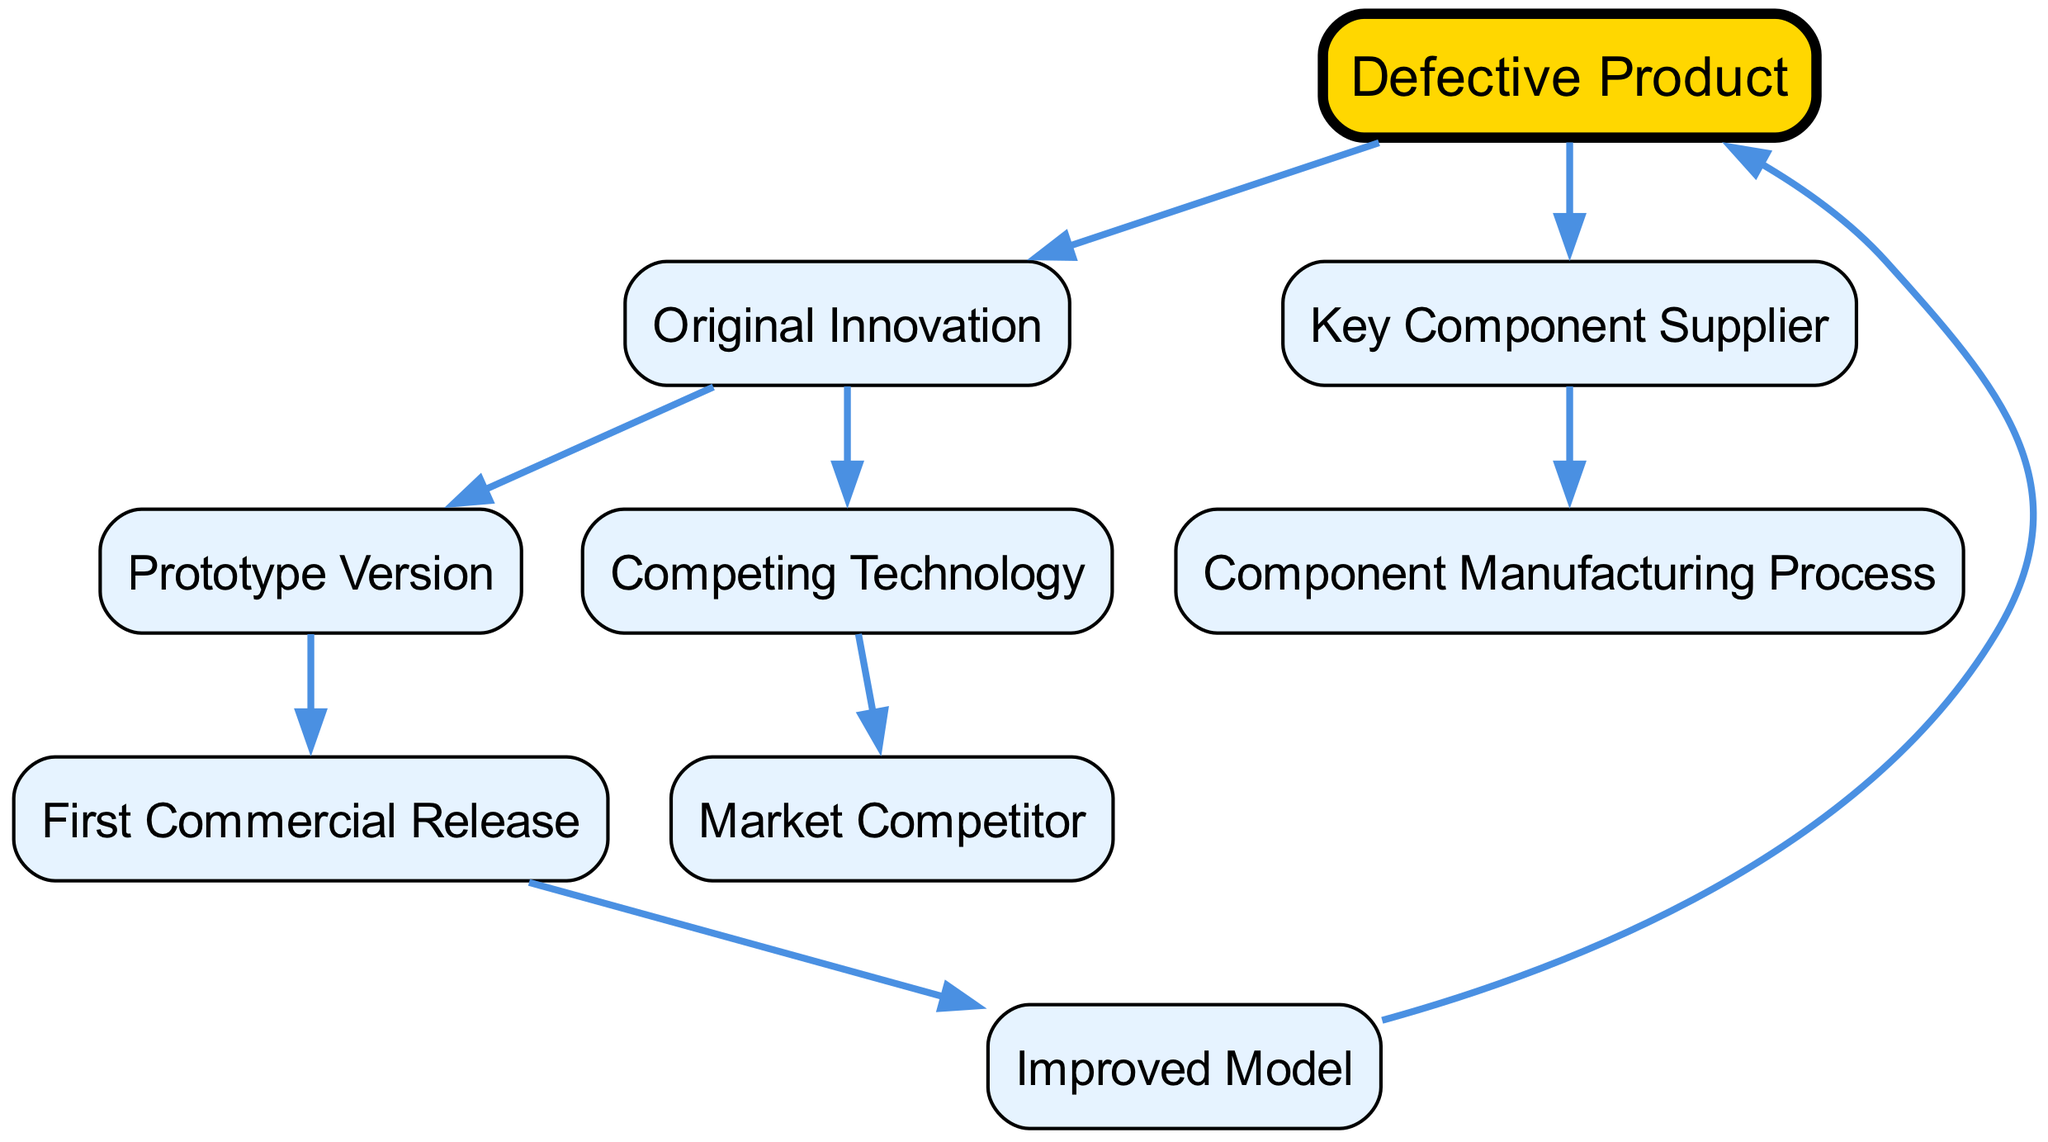What is the root of the family tree? The root node is the highest point in the diagram and represents the initial product being analyzed. In this case, the root is labeled "Defective Product."
Answer: Defective Product How many children does "Original Innovation" have? To determine the number of children for "Original Innovation," we can trace the connections from this node. The node has two children: "Prototype Version" and "Competing Technology."
Answer: 2 What is the direct predecessor of "Improved Model"? By following the connections from the node labeled "Improved Model," we see that its immediate parent is "First Commercial Release," which is its direct predecessor in the sequence of developments.
Answer: First Commercial Release Which technology directly competes with the "Defective Product"? The diagram indicates that "Competing Technology" leads to a node labeled "Market Competitor," suggesting it is the technology that directly competes with the product in question.
Answer: Market Competitor What is the relationship between "Key Component Supplier" and "Defective Product"? "Key Component Supplier" is an ancestor of the "Defective Product." Tracing the lines in the diagram, it shows that there is no direct lineage from "Key Component Supplier" to "Defective Product," but rather both descendants stem from the broader ancestry of the innovation.
Answer: Ancestor How many total nodes are present in this diagram? By counting all the nodes, including the root and all ancestors and their children, we can confirm that there are a total of eight nodes in the diagram: "Defective Product," "Original Innovation," "Key Component Supplier," "Prototype Version," "Competing Technology," "First Commercial Release," "Improved Model," and "Component Manufacturing Process."
Answer: 8 What is the lowest node in the family tree? To identify the lowest node, we look for the node that has no children. "Defective Product" is the final stage of development and does not branch further; hence, it is the lowest.
Answer: Defective Product Who is the immediate parent of "Component Manufacturing Process"? The tracing of "Component Manufacturing Process" leads us directly to "Key Component Supplier," which serves as its immediate parent in the hierarchy described in the diagram.
Answer: Key Component Supplier What is the first step before "First Commercial Release"? Following the flow of the family tree, the step that comes right before "First Commercial Release" is the "Prototype Version." Hence, it represents the information or stage just prior to the commercial launch.
Answer: Prototype Version 